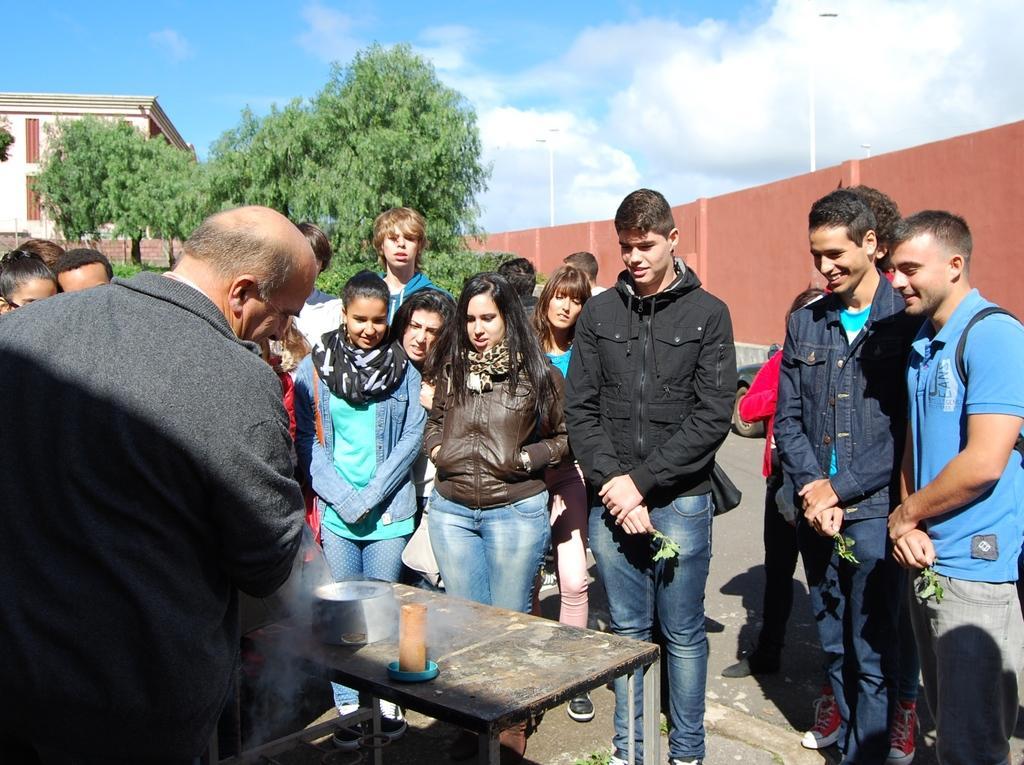Can you describe this image briefly? In this image we can see a few people standing on the ground. We can also see a table and on the table we can see two objects. In the background we can see the building, fencing wall, trees and also light poles. At the top there is sky with the clouds. 